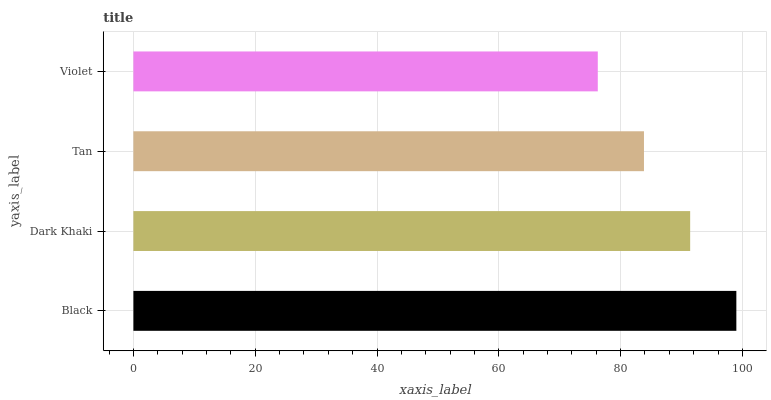Is Violet the minimum?
Answer yes or no. Yes. Is Black the maximum?
Answer yes or no. Yes. Is Dark Khaki the minimum?
Answer yes or no. No. Is Dark Khaki the maximum?
Answer yes or no. No. Is Black greater than Dark Khaki?
Answer yes or no. Yes. Is Dark Khaki less than Black?
Answer yes or no. Yes. Is Dark Khaki greater than Black?
Answer yes or no. No. Is Black less than Dark Khaki?
Answer yes or no. No. Is Dark Khaki the high median?
Answer yes or no. Yes. Is Tan the low median?
Answer yes or no. Yes. Is Violet the high median?
Answer yes or no. No. Is Violet the low median?
Answer yes or no. No. 